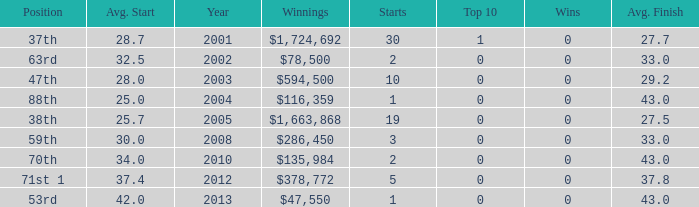How many wins for average start less than 25? 0.0. 